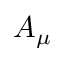Convert formula to latex. <formula><loc_0><loc_0><loc_500><loc_500>A _ { \mu }</formula> 